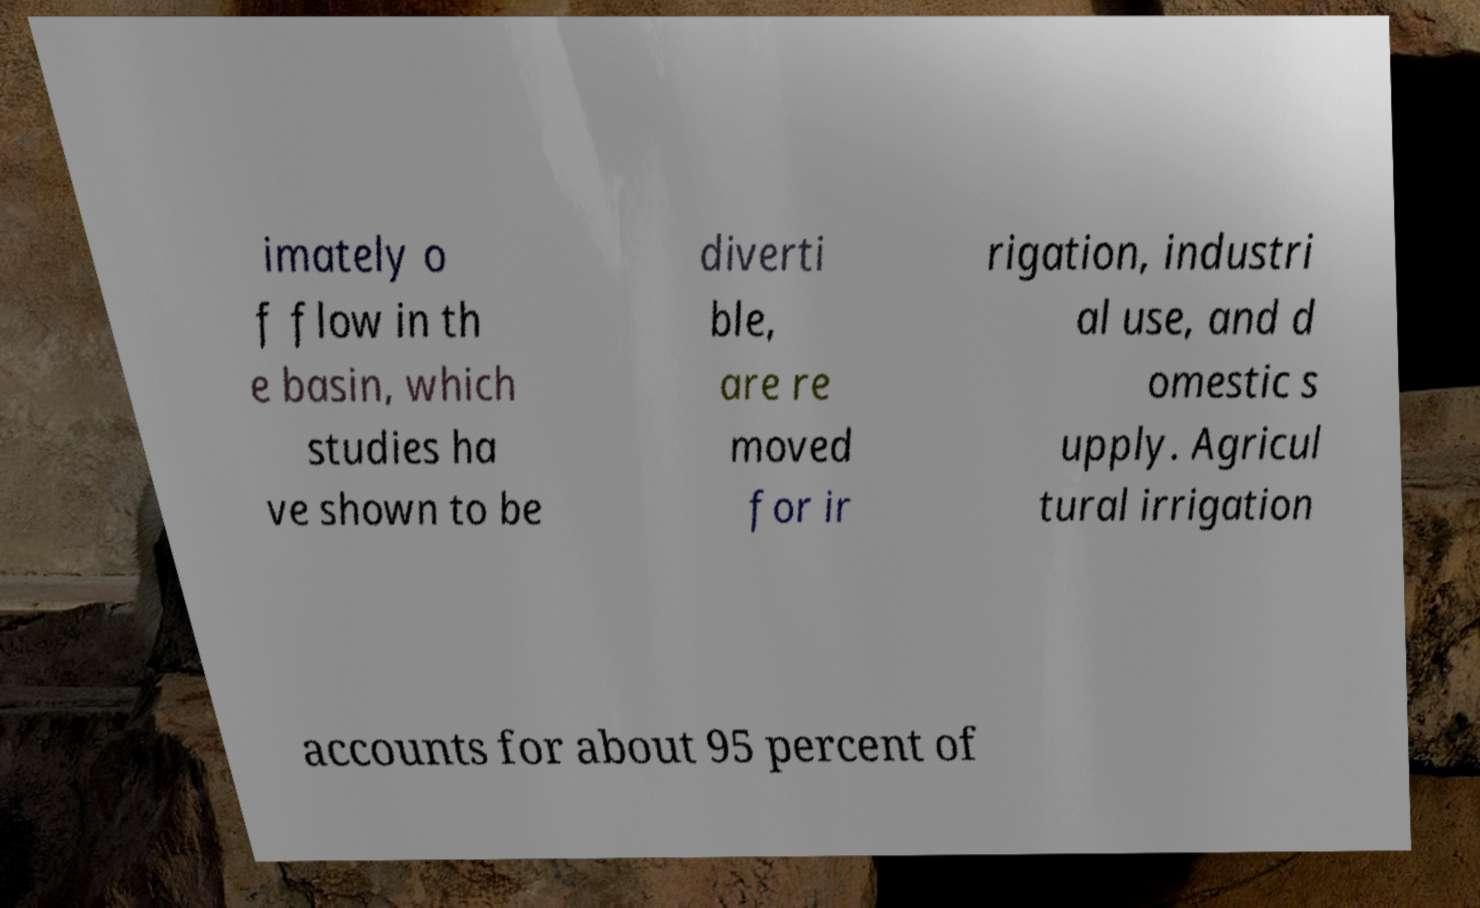Can you accurately transcribe the text from the provided image for me? imately o f flow in th e basin, which studies ha ve shown to be diverti ble, are re moved for ir rigation, industri al use, and d omestic s upply. Agricul tural irrigation accounts for about 95 percent of 